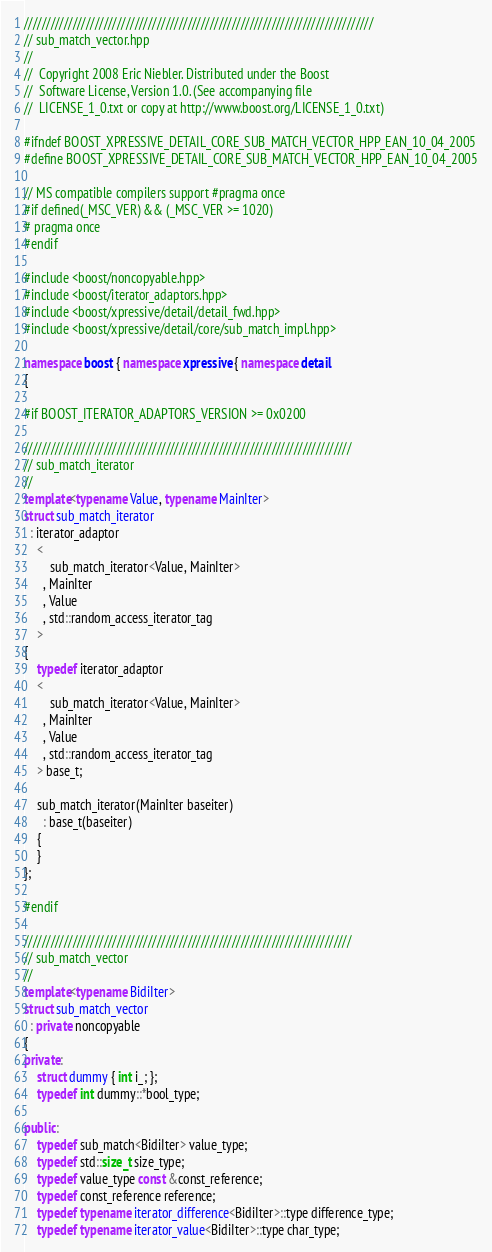Convert code to text. <code><loc_0><loc_0><loc_500><loc_500><_C++_>///////////////////////////////////////////////////////////////////////////////
// sub_match_vector.hpp
//
//  Copyright 2008 Eric Niebler. Distributed under the Boost
//  Software License, Version 1.0. (See accompanying file
//  LICENSE_1_0.txt or copy at http://www.boost.org/LICENSE_1_0.txt)

#ifndef BOOST_XPRESSIVE_DETAIL_CORE_SUB_MATCH_VECTOR_HPP_EAN_10_04_2005
#define BOOST_XPRESSIVE_DETAIL_CORE_SUB_MATCH_VECTOR_HPP_EAN_10_04_2005

// MS compatible compilers support #pragma once
#if defined(_MSC_VER) && (_MSC_VER >= 1020)
# pragma once
#endif

#include <boost/noncopyable.hpp>
#include <boost/iterator_adaptors.hpp>
#include <boost/xpressive/detail/detail_fwd.hpp>
#include <boost/xpressive/detail/core/sub_match_impl.hpp>

namespace boost { namespace xpressive { namespace detail
{

#if BOOST_ITERATOR_ADAPTORS_VERSION >= 0x0200

//////////////////////////////////////////////////////////////////////////
// sub_match_iterator
//
template<typename Value, typename MainIter>
struct sub_match_iterator
  : iterator_adaptor
    <
        sub_match_iterator<Value, MainIter>
      , MainIter
      , Value
      , std::random_access_iterator_tag
    >
{
    typedef iterator_adaptor
    <
        sub_match_iterator<Value, MainIter>
      , MainIter
      , Value
      , std::random_access_iterator_tag
    > base_t;

    sub_match_iterator(MainIter baseiter)
      : base_t(baseiter)
    {
    }
};

#endif

//////////////////////////////////////////////////////////////////////////
// sub_match_vector
//
template<typename BidiIter>
struct sub_match_vector
  : private noncopyable
{
private:
    struct dummy { int i_; };
    typedef int dummy::*bool_type;

public:
    typedef sub_match<BidiIter> value_type;
    typedef std::size_t size_type;
    typedef value_type const &const_reference;
    typedef const_reference reference;
    typedef typename iterator_difference<BidiIter>::type difference_type;
    typedef typename iterator_value<BidiIter>::type char_type;</code> 